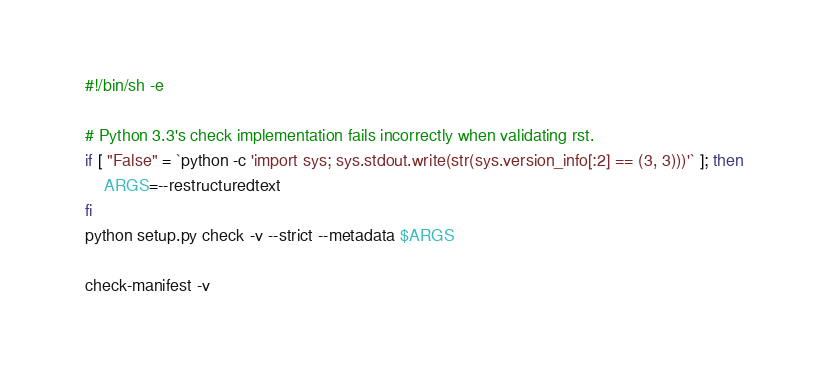<code> <loc_0><loc_0><loc_500><loc_500><_Bash_>#!/bin/sh -e

# Python 3.3's check implementation fails incorrectly when validating rst.
if [ "False" = `python -c 'import sys; sys.stdout.write(str(sys.version_info[:2] == (3, 3)))'` ]; then
    ARGS=--restructuredtext
fi
python setup.py check -v --strict --metadata $ARGS

check-manifest -v
</code> 